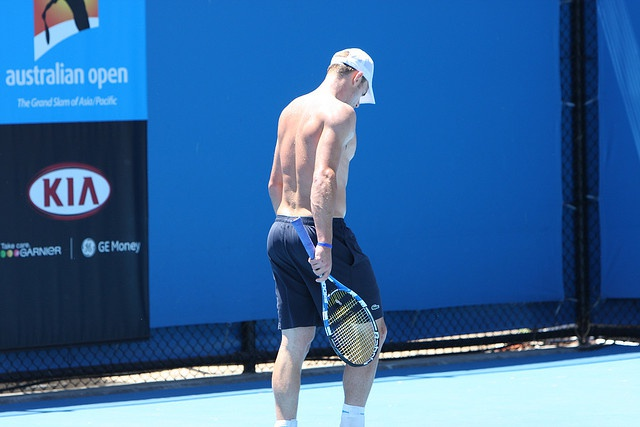Describe the objects in this image and their specific colors. I can see people in lightblue, darkgray, white, navy, and black tones and tennis racket in lightblue, black, navy, gray, and white tones in this image. 